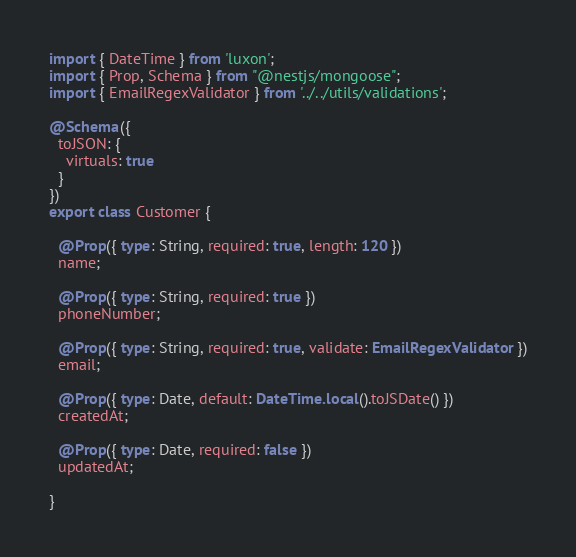Convert code to text. <code><loc_0><loc_0><loc_500><loc_500><_TypeScript_>import { DateTime } from 'luxon';
import { Prop, Schema } from "@nestjs/mongoose";
import { EmailRegexValidator } from '../../utils/validations';

@Schema({
  toJSON: {
    virtuals: true
  }
})
export class Customer {

  @Prop({ type: String, required: true, length: 120 })
  name;

  @Prop({ type: String, required: true })
  phoneNumber;

  @Prop({ type: String, required: true, validate: EmailRegexValidator })
  email;

  @Prop({ type: Date, default: DateTime.local().toJSDate() })
  createdAt;

  @Prop({ type: Date, required: false })
  updatedAt;

}
</code> 